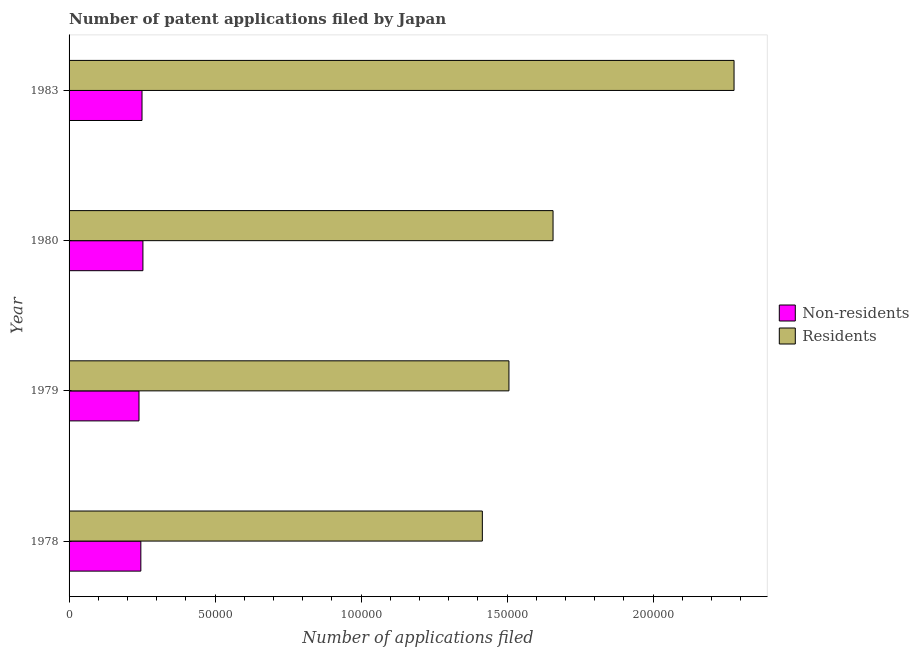How many different coloured bars are there?
Your response must be concise. 2. Are the number of bars per tick equal to the number of legend labels?
Offer a very short reply. Yes. Are the number of bars on each tick of the Y-axis equal?
Provide a short and direct response. Yes. What is the label of the 2nd group of bars from the top?
Give a very brief answer. 1980. In how many cases, is the number of bars for a given year not equal to the number of legend labels?
Keep it short and to the point. 0. What is the number of patent applications by non residents in 1979?
Offer a very short reply. 2.39e+04. Across all years, what is the maximum number of patent applications by residents?
Make the answer very short. 2.28e+05. Across all years, what is the minimum number of patent applications by non residents?
Your answer should be very brief. 2.39e+04. In which year was the number of patent applications by residents minimum?
Make the answer very short. 1978. What is the total number of patent applications by residents in the graph?
Make the answer very short. 6.86e+05. What is the difference between the number of patent applications by non residents in 1978 and that in 1980?
Offer a very short reply. -715. What is the difference between the number of patent applications by residents in 1979 and the number of patent applications by non residents in 1978?
Provide a short and direct response. 1.26e+05. What is the average number of patent applications by non residents per year?
Make the answer very short. 2.47e+04. In the year 1979, what is the difference between the number of patent applications by residents and number of patent applications by non residents?
Give a very brief answer. 1.27e+05. In how many years, is the number of patent applications by non residents greater than 150000 ?
Ensure brevity in your answer.  0. What is the ratio of the number of patent applications by non residents in 1979 to that in 1980?
Make the answer very short. 0.95. Is the number of patent applications by residents in 1980 less than that in 1983?
Offer a very short reply. Yes. What is the difference between the highest and the second highest number of patent applications by non residents?
Provide a succinct answer. 313. What is the difference between the highest and the lowest number of patent applications by non residents?
Provide a succinct answer. 1344. In how many years, is the number of patent applications by residents greater than the average number of patent applications by residents taken over all years?
Your response must be concise. 1. What does the 2nd bar from the top in 1983 represents?
Offer a terse response. Non-residents. What does the 1st bar from the bottom in 1980 represents?
Provide a succinct answer. Non-residents. How many years are there in the graph?
Provide a short and direct response. 4. Are the values on the major ticks of X-axis written in scientific E-notation?
Your response must be concise. No. Does the graph contain grids?
Your answer should be compact. No. Where does the legend appear in the graph?
Provide a succinct answer. Center right. How many legend labels are there?
Keep it short and to the point. 2. What is the title of the graph?
Offer a terse response. Number of patent applications filed by Japan. Does "Quality of trade" appear as one of the legend labels in the graph?
Your response must be concise. No. What is the label or title of the X-axis?
Your answer should be compact. Number of applications filed. What is the Number of applications filed of Non-residents in 1978?
Keep it short and to the point. 2.46e+04. What is the Number of applications filed of Residents in 1978?
Offer a terse response. 1.42e+05. What is the Number of applications filed of Non-residents in 1979?
Your response must be concise. 2.39e+04. What is the Number of applications filed in Residents in 1979?
Keep it short and to the point. 1.51e+05. What is the Number of applications filed of Non-residents in 1980?
Give a very brief answer. 2.53e+04. What is the Number of applications filed of Residents in 1980?
Give a very brief answer. 1.66e+05. What is the Number of applications filed of Non-residents in 1983?
Ensure brevity in your answer.  2.50e+04. What is the Number of applications filed in Residents in 1983?
Provide a succinct answer. 2.28e+05. Across all years, what is the maximum Number of applications filed of Non-residents?
Your answer should be very brief. 2.53e+04. Across all years, what is the maximum Number of applications filed in Residents?
Provide a short and direct response. 2.28e+05. Across all years, what is the minimum Number of applications filed of Non-residents?
Your answer should be very brief. 2.39e+04. Across all years, what is the minimum Number of applications filed in Residents?
Your answer should be very brief. 1.42e+05. What is the total Number of applications filed of Non-residents in the graph?
Give a very brief answer. 9.88e+04. What is the total Number of applications filed in Residents in the graph?
Make the answer very short. 6.86e+05. What is the difference between the Number of applications filed of Non-residents in 1978 and that in 1979?
Offer a terse response. 629. What is the difference between the Number of applications filed of Residents in 1978 and that in 1979?
Provide a succinct answer. -9106. What is the difference between the Number of applications filed in Non-residents in 1978 and that in 1980?
Your answer should be very brief. -715. What is the difference between the Number of applications filed in Residents in 1978 and that in 1980?
Your answer should be very brief. -2.42e+04. What is the difference between the Number of applications filed of Non-residents in 1978 and that in 1983?
Ensure brevity in your answer.  -402. What is the difference between the Number of applications filed in Residents in 1978 and that in 1983?
Offer a terse response. -8.62e+04. What is the difference between the Number of applications filed of Non-residents in 1979 and that in 1980?
Offer a terse response. -1344. What is the difference between the Number of applications filed of Residents in 1979 and that in 1980?
Make the answer very short. -1.51e+04. What is the difference between the Number of applications filed in Non-residents in 1979 and that in 1983?
Your response must be concise. -1031. What is the difference between the Number of applications filed in Residents in 1979 and that in 1983?
Keep it short and to the point. -7.71e+04. What is the difference between the Number of applications filed of Non-residents in 1980 and that in 1983?
Your response must be concise. 313. What is the difference between the Number of applications filed of Residents in 1980 and that in 1983?
Ensure brevity in your answer.  -6.20e+04. What is the difference between the Number of applications filed of Non-residents in 1978 and the Number of applications filed of Residents in 1979?
Your answer should be very brief. -1.26e+05. What is the difference between the Number of applications filed of Non-residents in 1978 and the Number of applications filed of Residents in 1980?
Your answer should be compact. -1.41e+05. What is the difference between the Number of applications filed in Non-residents in 1978 and the Number of applications filed in Residents in 1983?
Offer a terse response. -2.03e+05. What is the difference between the Number of applications filed of Non-residents in 1979 and the Number of applications filed of Residents in 1980?
Make the answer very short. -1.42e+05. What is the difference between the Number of applications filed in Non-residents in 1979 and the Number of applications filed in Residents in 1983?
Provide a succinct answer. -2.04e+05. What is the difference between the Number of applications filed in Non-residents in 1980 and the Number of applications filed in Residents in 1983?
Your answer should be compact. -2.02e+05. What is the average Number of applications filed in Non-residents per year?
Ensure brevity in your answer.  2.47e+04. What is the average Number of applications filed in Residents per year?
Give a very brief answer. 1.71e+05. In the year 1978, what is the difference between the Number of applications filed in Non-residents and Number of applications filed in Residents?
Offer a terse response. -1.17e+05. In the year 1979, what is the difference between the Number of applications filed of Non-residents and Number of applications filed of Residents?
Give a very brief answer. -1.27e+05. In the year 1980, what is the difference between the Number of applications filed in Non-residents and Number of applications filed in Residents?
Keep it short and to the point. -1.40e+05. In the year 1983, what is the difference between the Number of applications filed in Non-residents and Number of applications filed in Residents?
Give a very brief answer. -2.03e+05. What is the ratio of the Number of applications filed of Non-residents in 1978 to that in 1979?
Ensure brevity in your answer.  1.03. What is the ratio of the Number of applications filed in Residents in 1978 to that in 1979?
Give a very brief answer. 0.94. What is the ratio of the Number of applications filed in Non-residents in 1978 to that in 1980?
Provide a succinct answer. 0.97. What is the ratio of the Number of applications filed in Residents in 1978 to that in 1980?
Ensure brevity in your answer.  0.85. What is the ratio of the Number of applications filed in Non-residents in 1978 to that in 1983?
Ensure brevity in your answer.  0.98. What is the ratio of the Number of applications filed in Residents in 1978 to that in 1983?
Your answer should be compact. 0.62. What is the ratio of the Number of applications filed of Non-residents in 1979 to that in 1980?
Keep it short and to the point. 0.95. What is the ratio of the Number of applications filed of Residents in 1979 to that in 1980?
Your response must be concise. 0.91. What is the ratio of the Number of applications filed of Non-residents in 1979 to that in 1983?
Offer a terse response. 0.96. What is the ratio of the Number of applications filed of Residents in 1979 to that in 1983?
Offer a very short reply. 0.66. What is the ratio of the Number of applications filed of Non-residents in 1980 to that in 1983?
Offer a terse response. 1.01. What is the ratio of the Number of applications filed in Residents in 1980 to that in 1983?
Offer a very short reply. 0.73. What is the difference between the highest and the second highest Number of applications filed of Non-residents?
Your answer should be very brief. 313. What is the difference between the highest and the second highest Number of applications filed of Residents?
Offer a very short reply. 6.20e+04. What is the difference between the highest and the lowest Number of applications filed in Non-residents?
Keep it short and to the point. 1344. What is the difference between the highest and the lowest Number of applications filed of Residents?
Give a very brief answer. 8.62e+04. 